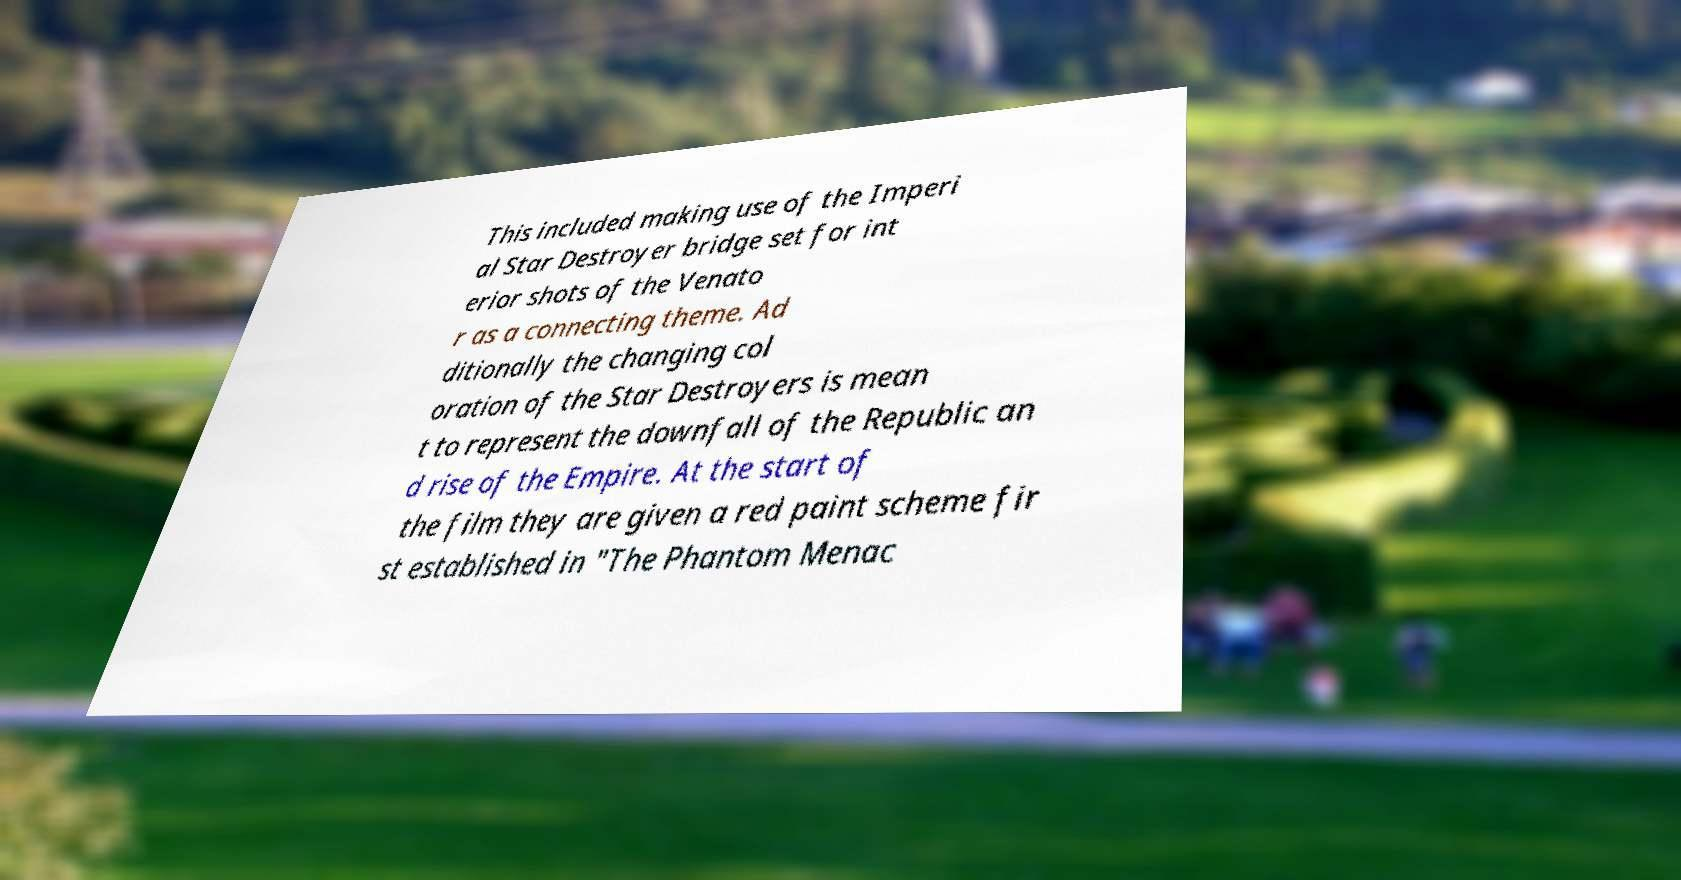Please identify and transcribe the text found in this image. This included making use of the Imperi al Star Destroyer bridge set for int erior shots of the Venato r as a connecting theme. Ad ditionally the changing col oration of the Star Destroyers is mean t to represent the downfall of the Republic an d rise of the Empire. At the start of the film they are given a red paint scheme fir st established in "The Phantom Menac 